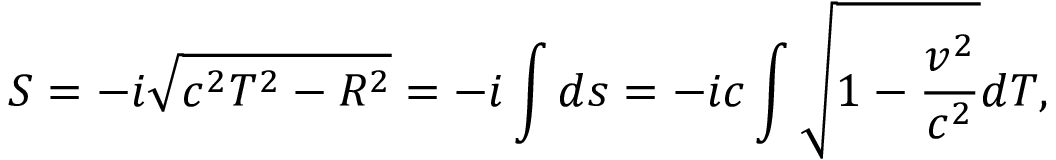<formula> <loc_0><loc_0><loc_500><loc_500>S = - i \sqrt { c ^ { 2 } T ^ { 2 } - R ^ { 2 } } = - i \int d s = - i c \int \sqrt { 1 - \frac { v ^ { 2 } } { c ^ { 2 } } } d T ,</formula> 